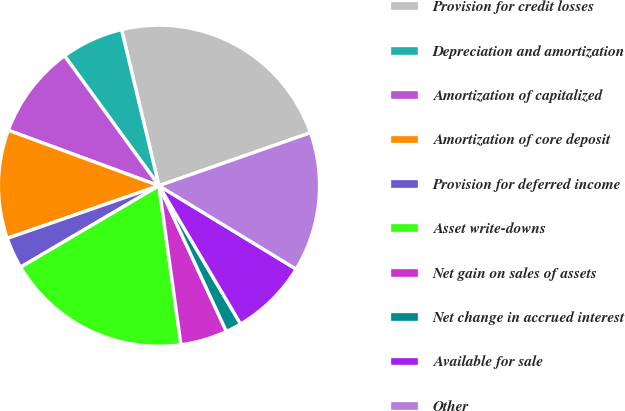Convert chart. <chart><loc_0><loc_0><loc_500><loc_500><pie_chart><fcel>Provision for credit losses<fcel>Depreciation and amortization<fcel>Amortization of capitalized<fcel>Amortization of core deposit<fcel>Provision for deferred income<fcel>Asset write-downs<fcel>Net gain on sales of assets<fcel>Net change in accrued interest<fcel>Available for sale<fcel>Other<nl><fcel>23.39%<fcel>6.26%<fcel>9.38%<fcel>10.93%<fcel>3.15%<fcel>18.72%<fcel>4.71%<fcel>1.59%<fcel>7.82%<fcel>14.05%<nl></chart> 